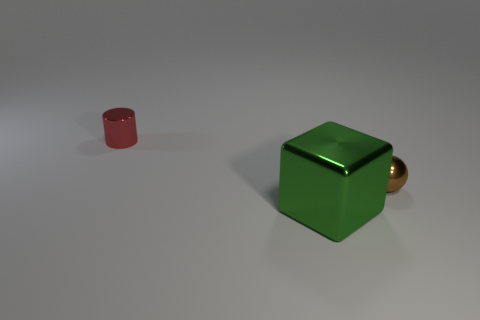Are there fewer small spheres that are on the left side of the tiny red metallic object than small yellow spheres?
Provide a short and direct response. No. The ball is what color?
Ensure brevity in your answer.  Brown. How many big objects are red matte spheres or balls?
Provide a succinct answer. 0. There is a object in front of the brown metallic sphere; how big is it?
Provide a short and direct response. Large. What number of shiny balls are to the right of the small metallic object behind the small brown sphere?
Offer a very short reply. 1. How many tiny balls are the same material as the red object?
Provide a short and direct response. 1. There is a tiny red cylinder; are there any green objects in front of it?
Offer a very short reply. Yes. What is the color of the metal object that is the same size as the cylinder?
Your answer should be compact. Brown. What number of things are either metal things that are to the left of the tiny sphere or gray metallic cylinders?
Offer a very short reply. 2. There is a thing that is behind the big green thing and to the left of the tiny brown ball; what size is it?
Provide a short and direct response. Small. 